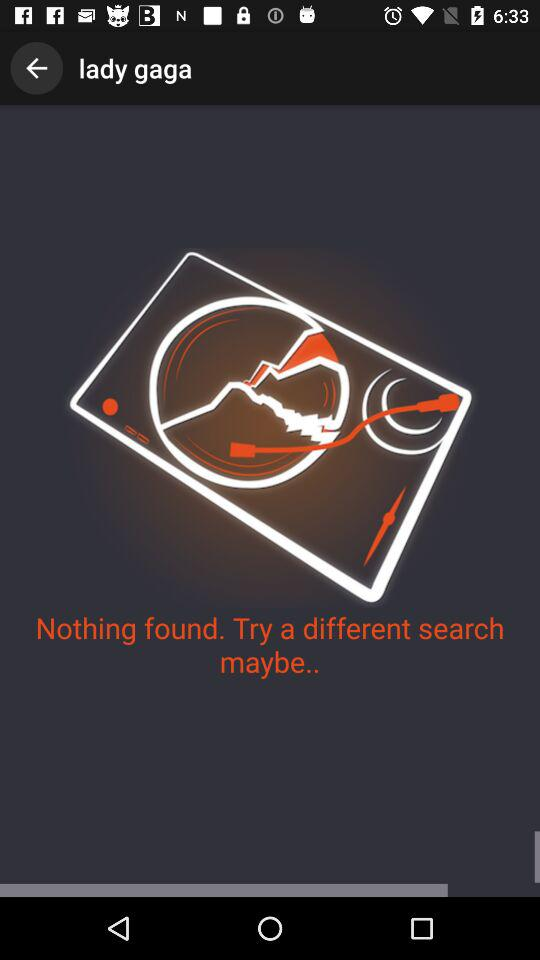What is written in the toolbar? In the toolbar, Lady Gaga is written. 